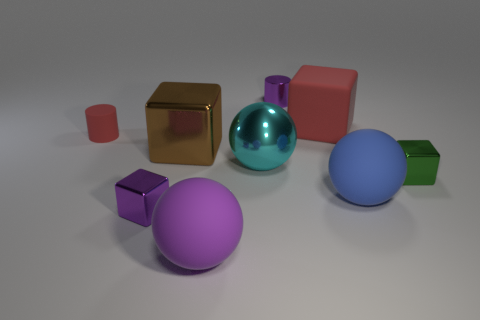Are there fewer purple balls that are behind the small rubber object than large rubber cubes that are behind the purple cube?
Your answer should be compact. Yes. The block that is both on the left side of the big red matte block and behind the blue matte object is made of what material?
Keep it short and to the point. Metal. What shape is the tiny metallic thing that is to the right of the tiny object behind the large red matte cube?
Your answer should be very brief. Cube. Do the small rubber thing and the large rubber cube have the same color?
Offer a terse response. Yes. What number of cyan objects are tiny metal cubes or big matte things?
Offer a very short reply. 0. Are there any small shiny cylinders right of the tiny rubber cylinder?
Your response must be concise. Yes. How big is the blue sphere?
Ensure brevity in your answer.  Large. There is a purple thing that is the same shape as the big red matte object; what is its size?
Keep it short and to the point. Small. What number of large cyan metal objects are on the right side of the red matte object that is to the right of the brown metallic cube?
Provide a succinct answer. 0. Is the material of the thing behind the large matte cube the same as the red object that is behind the small matte cylinder?
Provide a short and direct response. No. 